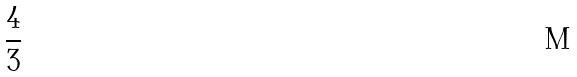Convert formula to latex. <formula><loc_0><loc_0><loc_500><loc_500>\frac { 4 } { 3 }</formula> 